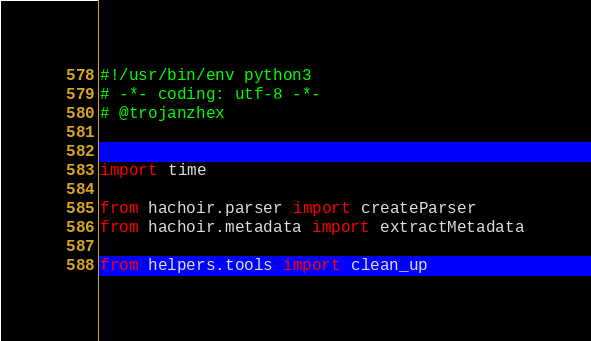Convert code to text. <code><loc_0><loc_0><loc_500><loc_500><_Python_>#!/usr/bin/env python3
# -*- coding: utf-8 -*-
# @trojanzhex


import time

from hachoir.parser import createParser
from hachoir.metadata import extractMetadata

from helpers.tools import clean_up</code> 